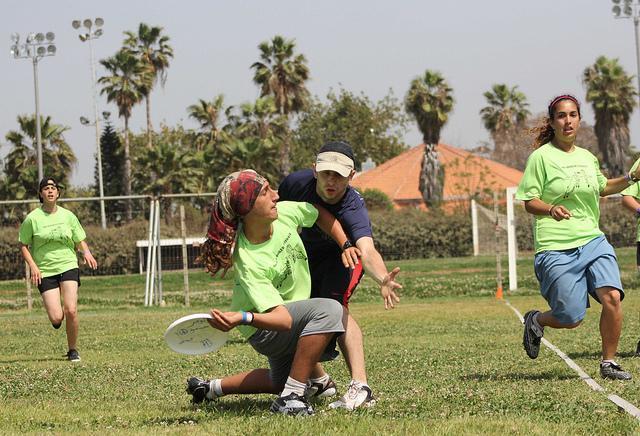How many people in this photo are on the green team?
Give a very brief answer. 4. How many people can you see?
Give a very brief answer. 4. 